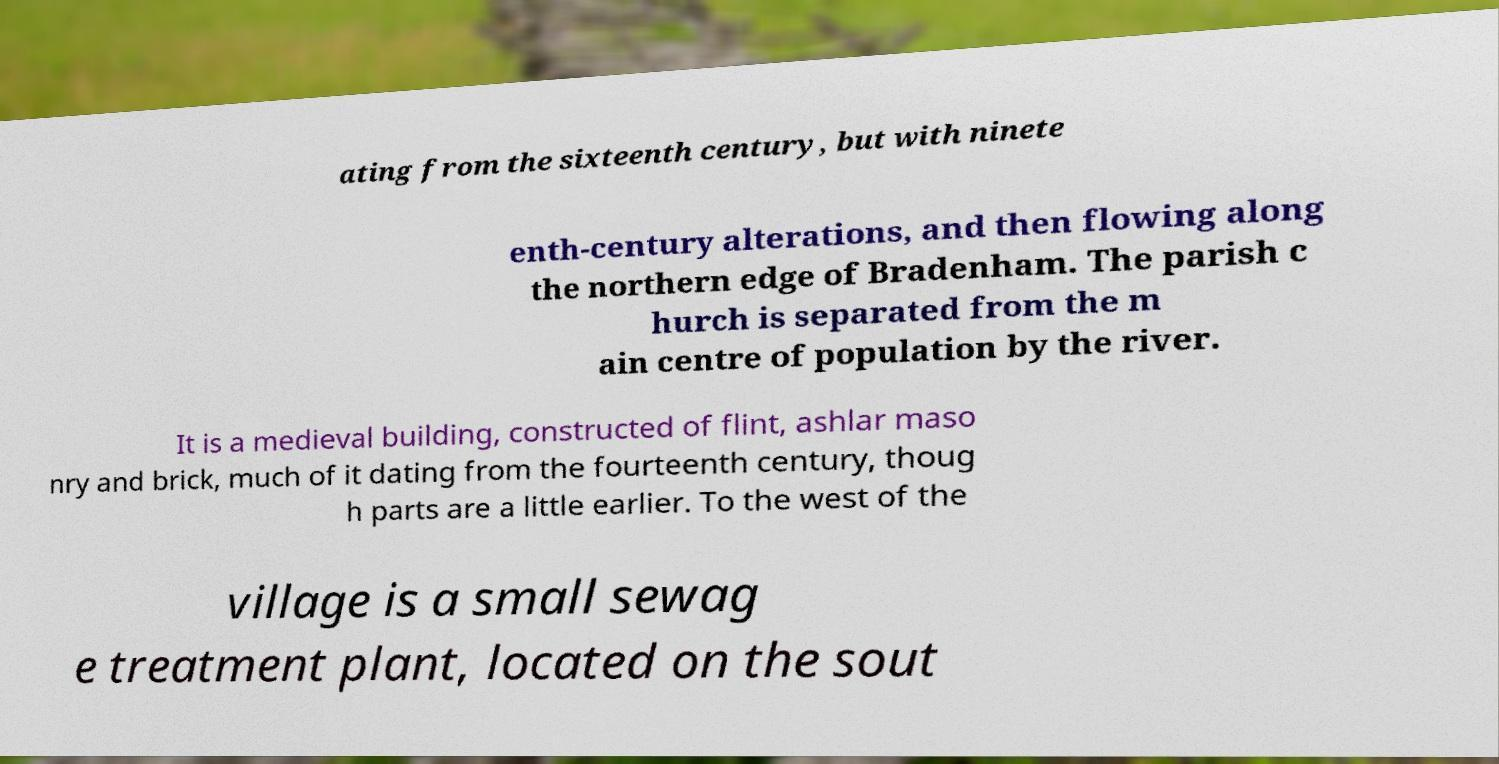There's text embedded in this image that I need extracted. Can you transcribe it verbatim? ating from the sixteenth century, but with ninete enth-century alterations, and then flowing along the northern edge of Bradenham. The parish c hurch is separated from the m ain centre of population by the river. It is a medieval building, constructed of flint, ashlar maso nry and brick, much of it dating from the fourteenth century, thoug h parts are a little earlier. To the west of the village is a small sewag e treatment plant, located on the sout 